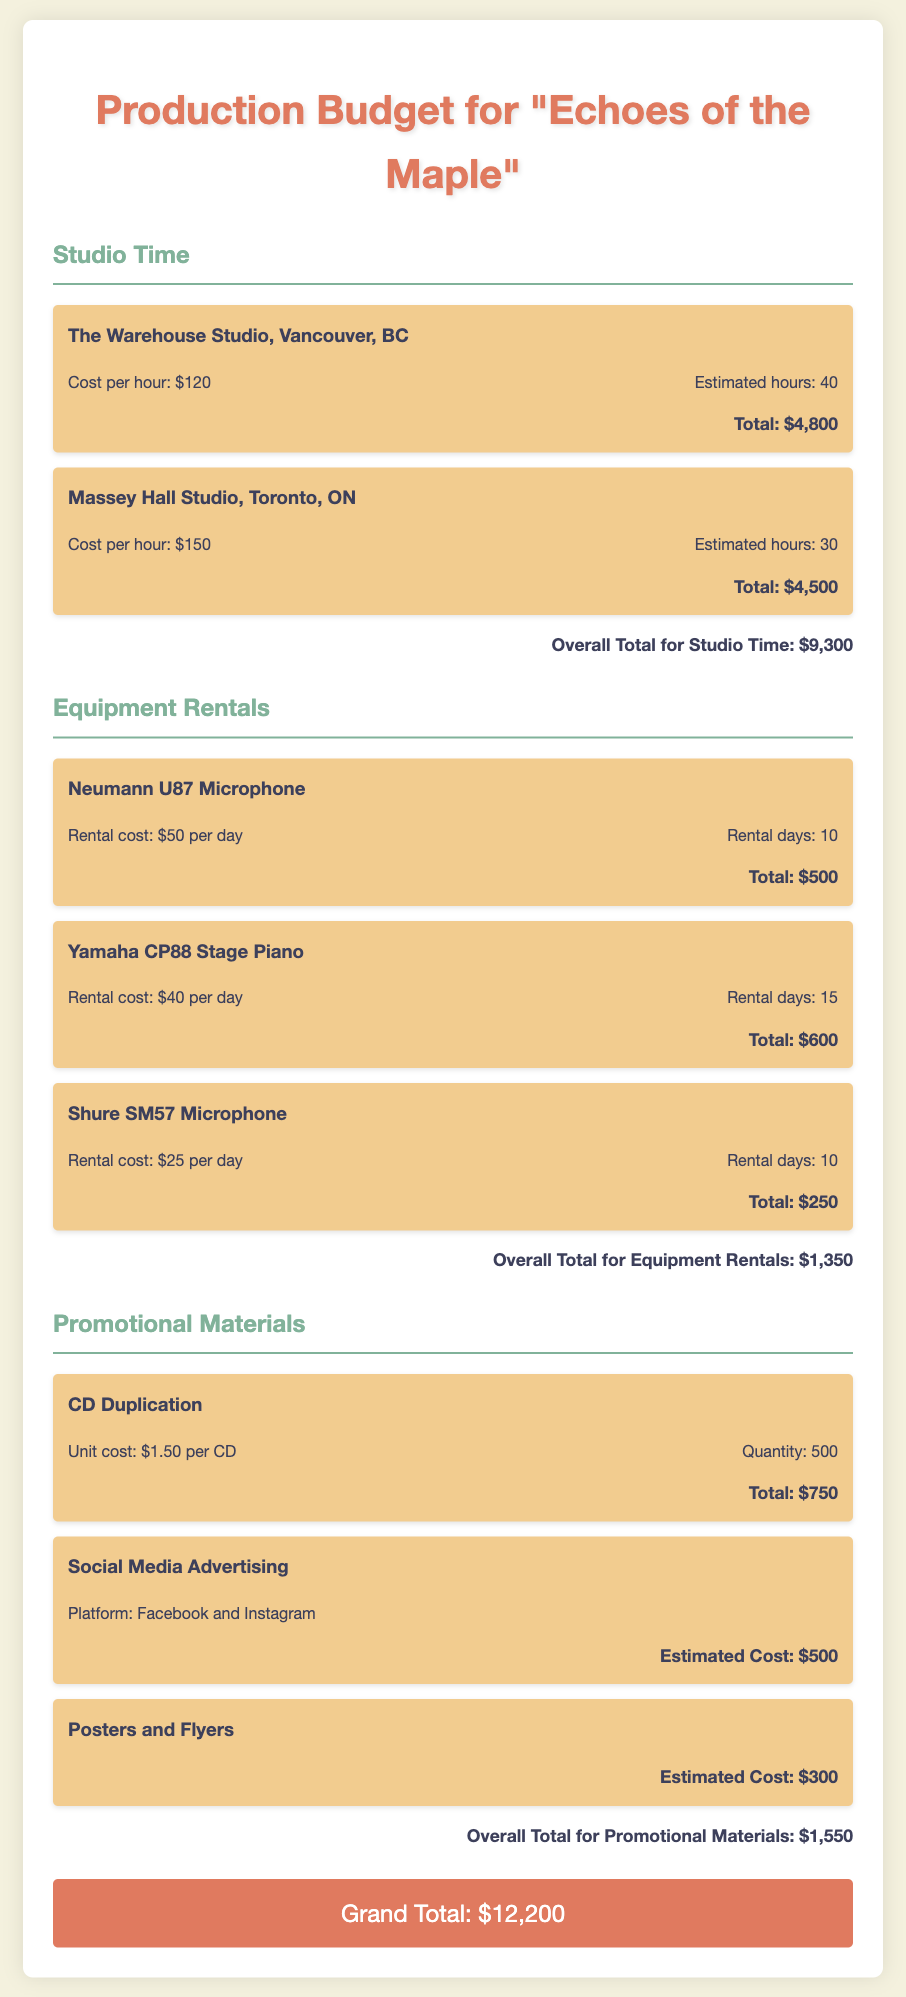What is the total cost for studio time? The total cost for studio time is shown in the document as the sum of costs for both studios.
Answer: $9,300 How much does it cost to rent the Neumann U87 Microphone? The rental cost details indicate the total for renting the Neumann U87 Microphone.
Answer: $500 What is the estimated cost for promotional materials? The total estimated cost for promotional materials is provided in the document.
Answer: $1,550 How long is the rental period for the Yamaha CP88 Stage Piano? The document specifies the number of days the Yamaha CP88 Stage Piano is rented.
Answer: 15 What is the grand total for the production budget? The grand total is the sum of all costs detailed in the document.
Answer: $12,200 Which studio has the higher cost per hour? The document gives the cost per hour for both studios, allowing for comparison.
Answer: Massey Hall Studio How many CDs are planned to be duplicated? The quantity for CD duplication is listed in the document.
Answer: 500 What is the total cost for the Shure SM57 Microphone rental? The document shows the total rental cost for the Shure SM57 Microphone.
Answer: $250 What is the cost per hour for The Warehouse Studio? The document specifies the hourly rate for The Warehouse Studio.
Answer: $120 